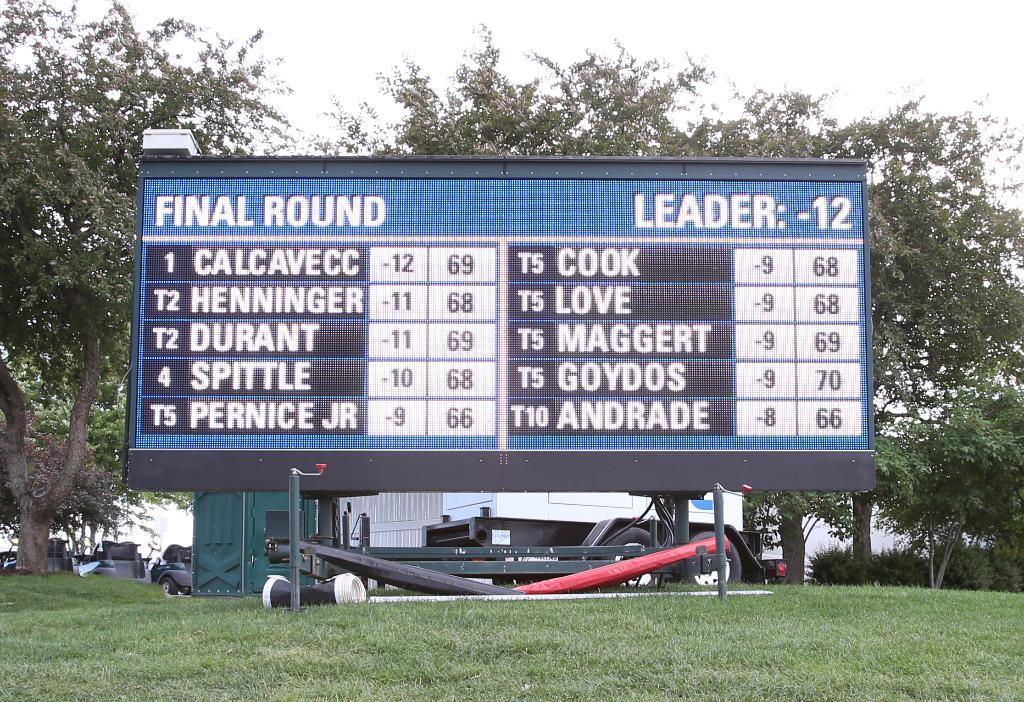Provide a one-sentence caption for the provided image. a scoreboard that says 'final round leader:-12' on it. 